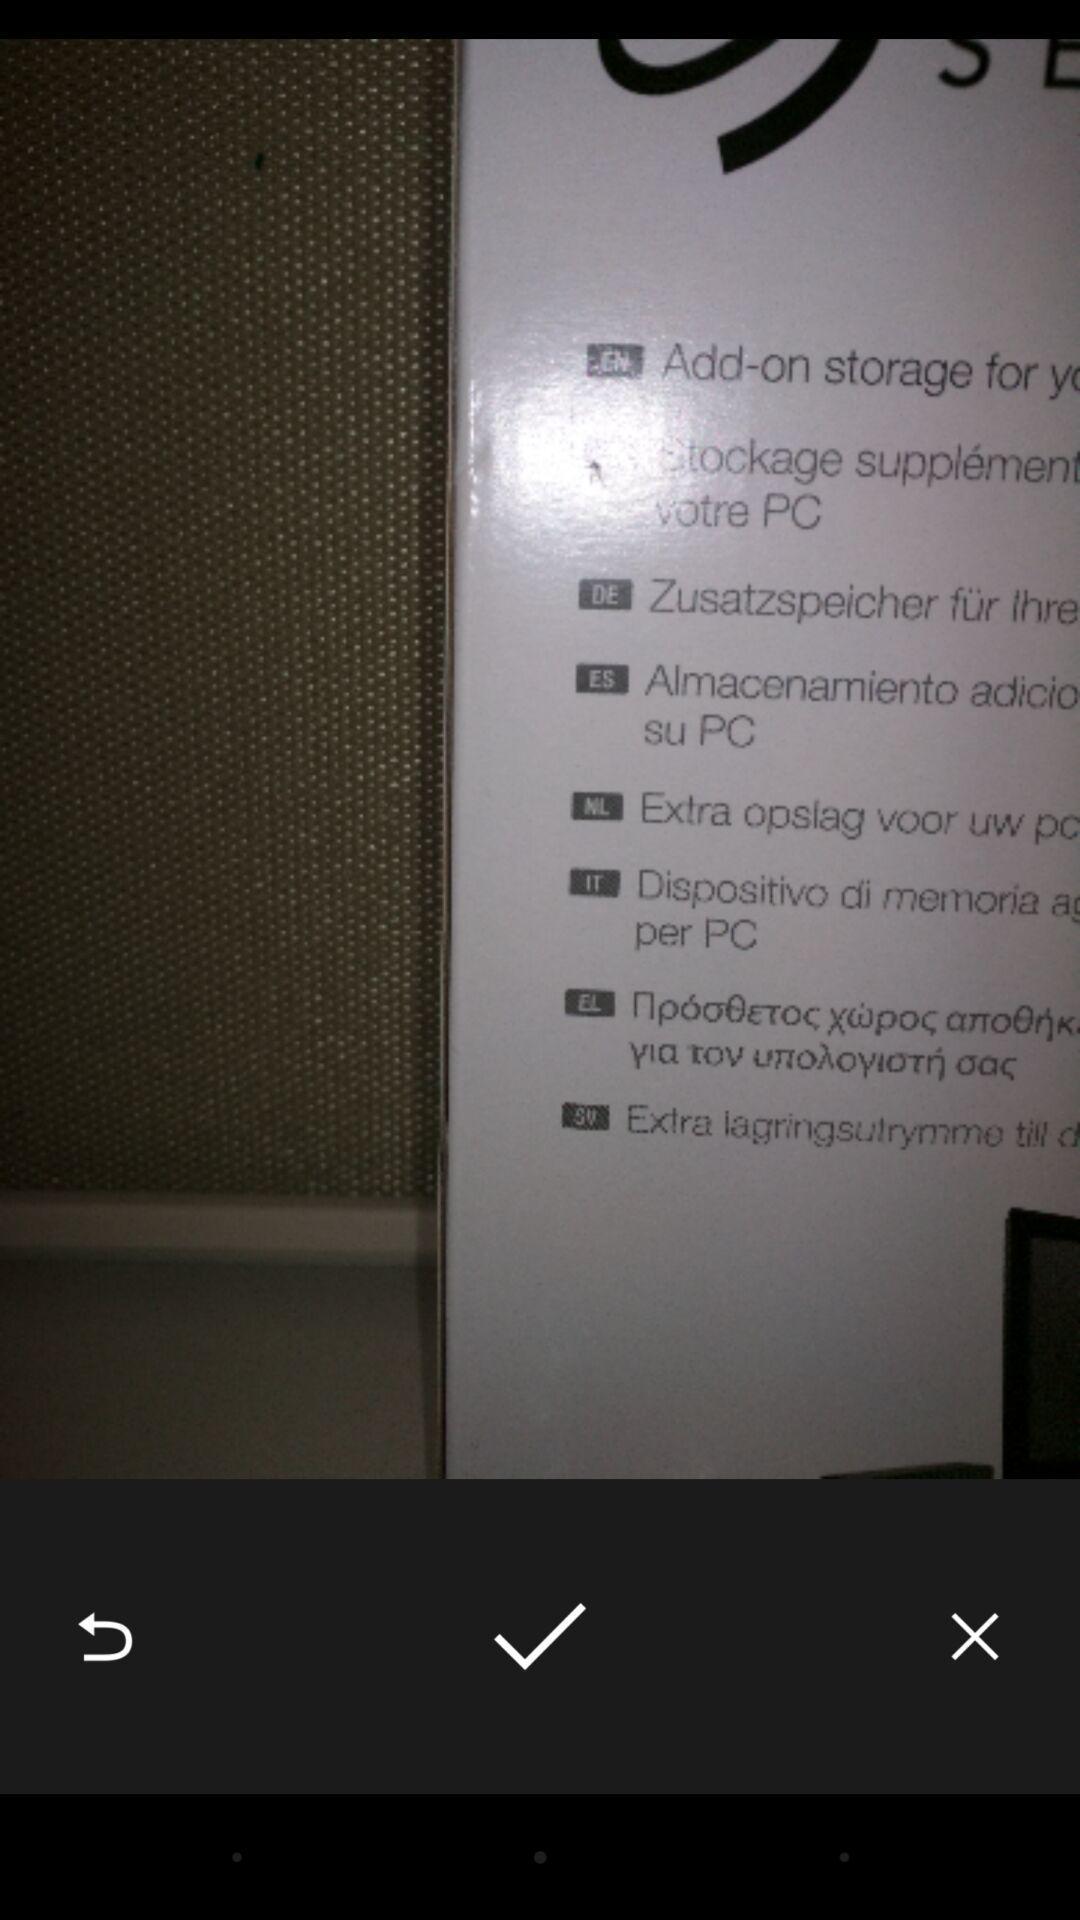What details can you identify in this image? Screen displaying an image with multiple controls. 